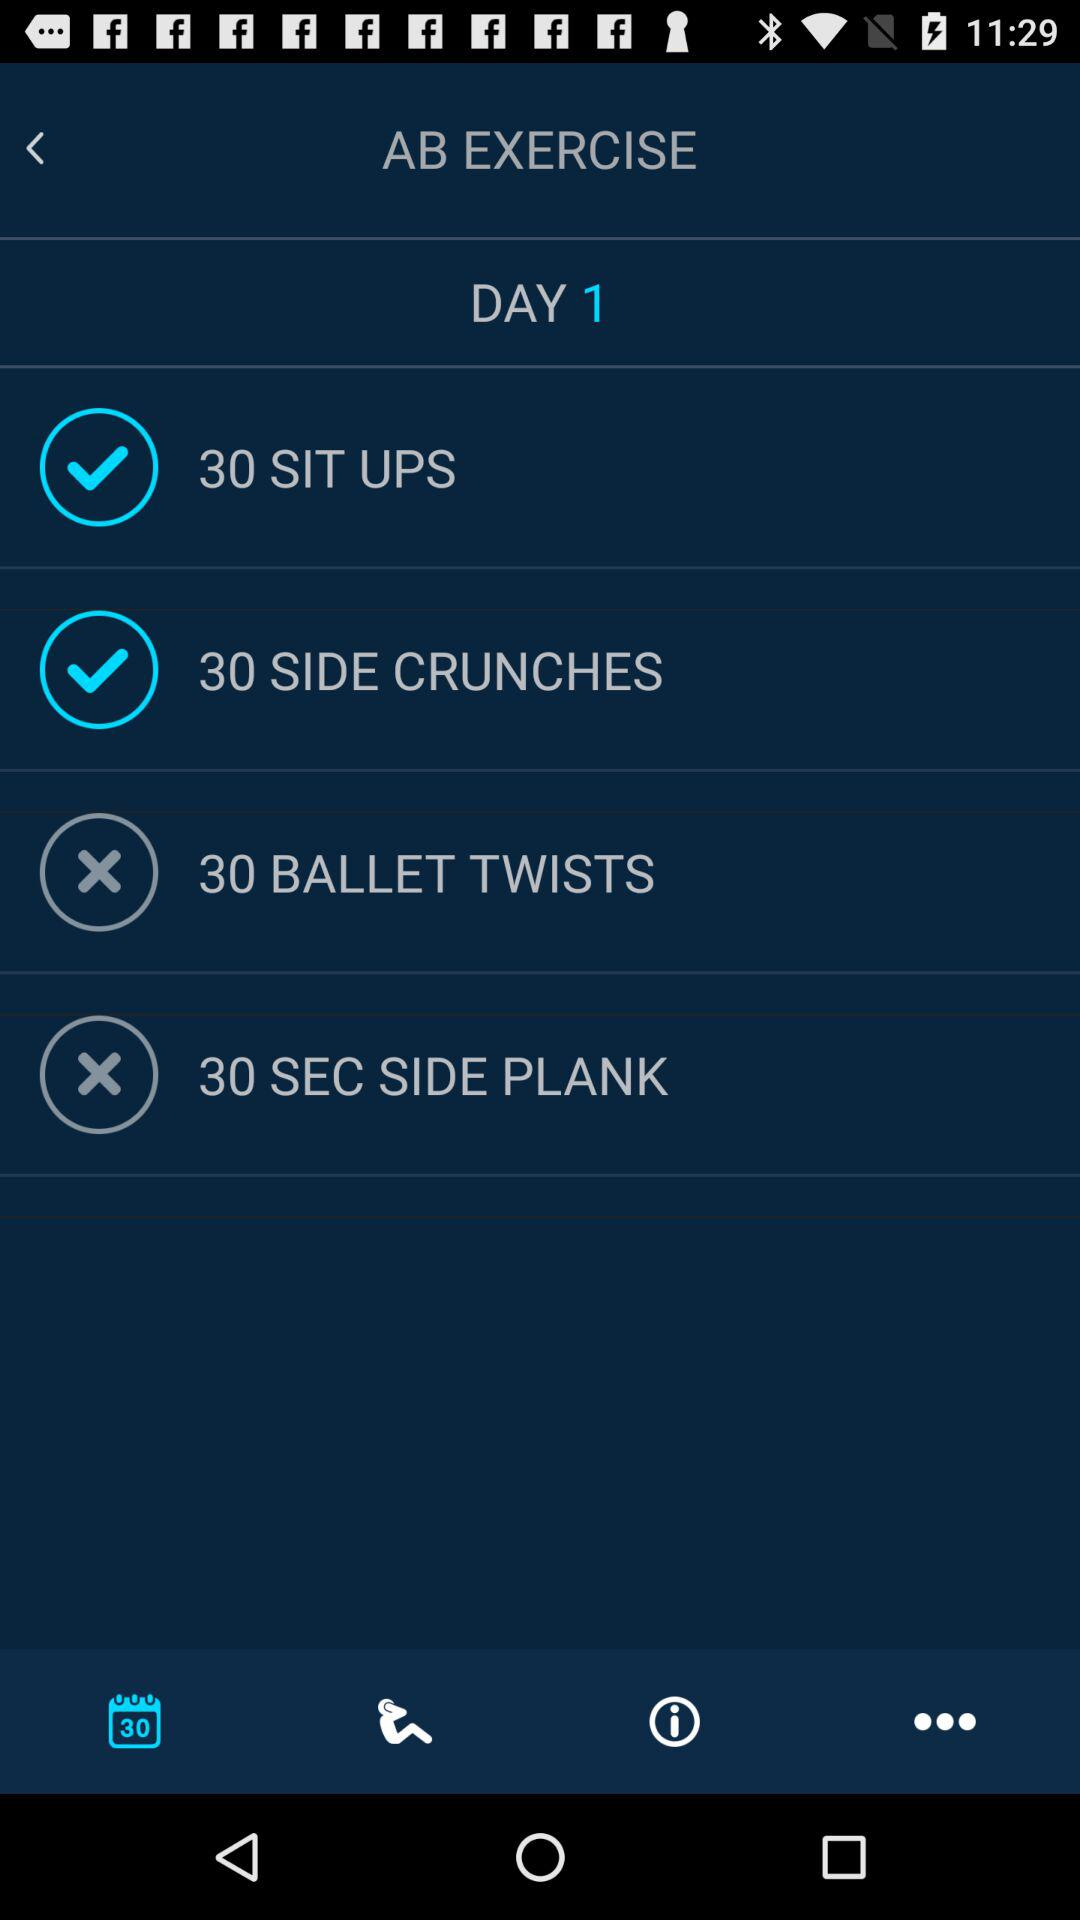What is the number of side crunches? The number of side crunches is 30. 